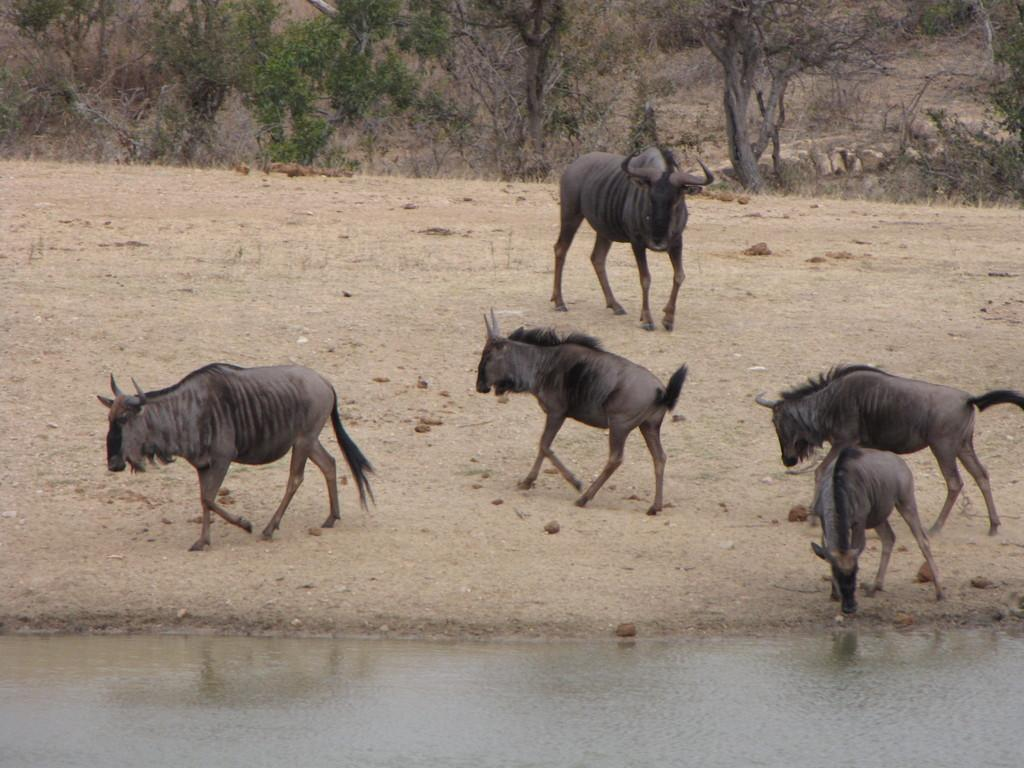What types of living organisms can be seen in the image? There are animals in the image. What is the primary element visible in the image? There is water visible in the image. What can be seen in the background of the image? There are trees in the background of the image. What type of dress is the shade wearing in the image? There is no shade or dress present in the image. 